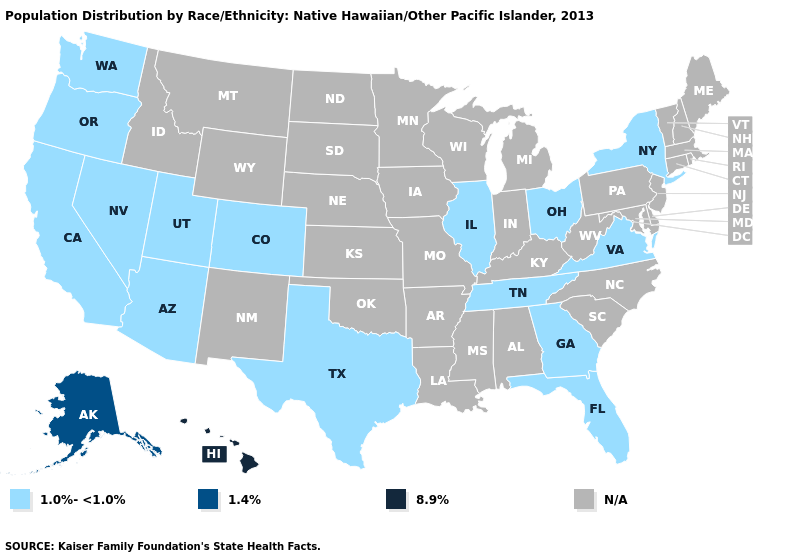Does Arizona have the highest value in the USA?
Write a very short answer. No. Which states have the lowest value in the USA?
Short answer required. Arizona, California, Colorado, Florida, Georgia, Illinois, Nevada, New York, Ohio, Oregon, Tennessee, Texas, Utah, Virginia, Washington. What is the highest value in the USA?
Keep it brief. 8.9%. What is the lowest value in states that border West Virginia?
Answer briefly. 1.0%-<1.0%. Does the map have missing data?
Keep it brief. Yes. Does the first symbol in the legend represent the smallest category?
Keep it brief. Yes. What is the value of Montana?
Keep it brief. N/A. Does Ohio have the highest value in the USA?
Be succinct. No. Does Tennessee have the lowest value in the USA?
Quick response, please. Yes. How many symbols are there in the legend?
Keep it brief. 4. Among the states that border New Mexico , which have the lowest value?
Write a very short answer. Arizona, Colorado, Texas, Utah. What is the value of Maryland?
Quick response, please. N/A. What is the value of Arkansas?
Quick response, please. N/A. 